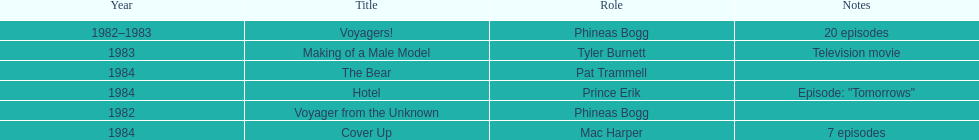In how many titles on this list did he not play the role of phineas bogg? 4. 